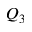<formula> <loc_0><loc_0><loc_500><loc_500>Q _ { 3 }</formula> 